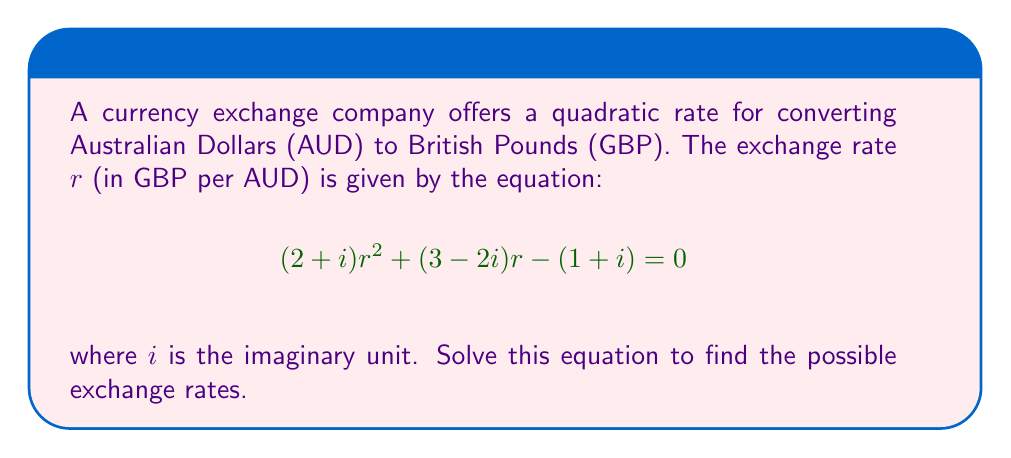Could you help me with this problem? To solve this quadratic equation with complex coefficients, we'll use the quadratic formula:

$$r = \frac{-b \pm \sqrt{b^2 - 4ac}}{2a}$$

where $a = 2+i$, $b = 3-2i$, and $c = -(1+i)$

Step 1: Calculate $b^2$
$b^2 = (3-2i)^2 = 9 - 12i + 4i^2 = 5 - 12i$

Step 2: Calculate $4ac$
$4ac = 4(2+i)(-(1+i)) = -8 - 4i - 4i - 4i^2 = -4 - 8i$

Step 3: Calculate $b^2 - 4ac$
$b^2 - 4ac = (5 - 12i) - (-4 - 8i) = 9 - 4i$

Step 4: Calculate $\sqrt{b^2 - 4ac}$
$\sqrt{9 - 4i} = 3 - \frac{2}{3}i$

Step 5: Calculate $-b$
$-b = -(3-2i) = -3 + 2i$

Step 6: Calculate $2a$
$2a = 2(2+i) = 4 + 2i$

Step 7: Apply the quadratic formula
$$r = \frac{(-3 + 2i) \pm (3 - \frac{2}{3}i)}{4 + 2i}$$

Step 8: Simplify the numerator for both cases
$r_1 = \frac{0 + \frac{4}{3}i}{4 + 2i}$
$r_2 = \frac{-6 + \frac{8}{3}i}{4 + 2i}$

Step 9: Rationalize the denominators
$r_1 = \frac{0 + \frac{4}{3}i}{4 + 2i} \cdot \frac{4 - 2i}{4 - 2i} = \frac{\frac{8}{3} + \frac{16}{3}i}{20} = \frac{4}{30} + \frac{8}{30}i$
$r_2 = \frac{-6 + \frac{8}{3}i}{4 + 2i} \cdot \frac{4 - 2i}{4 - 2i} = \frac{-24 - 12i + \frac{32}{3} + \frac{16}{3}i}{20} = \frac{-72 + 32 - 36i + 16i}{60} = -\frac{2}{3} - \frac{1}{3}i$
Answer: $r_1 = \frac{2}{15} + \frac{4}{15}i$ and $r_2 = -\frac{2}{3} - \frac{1}{3}i$ 